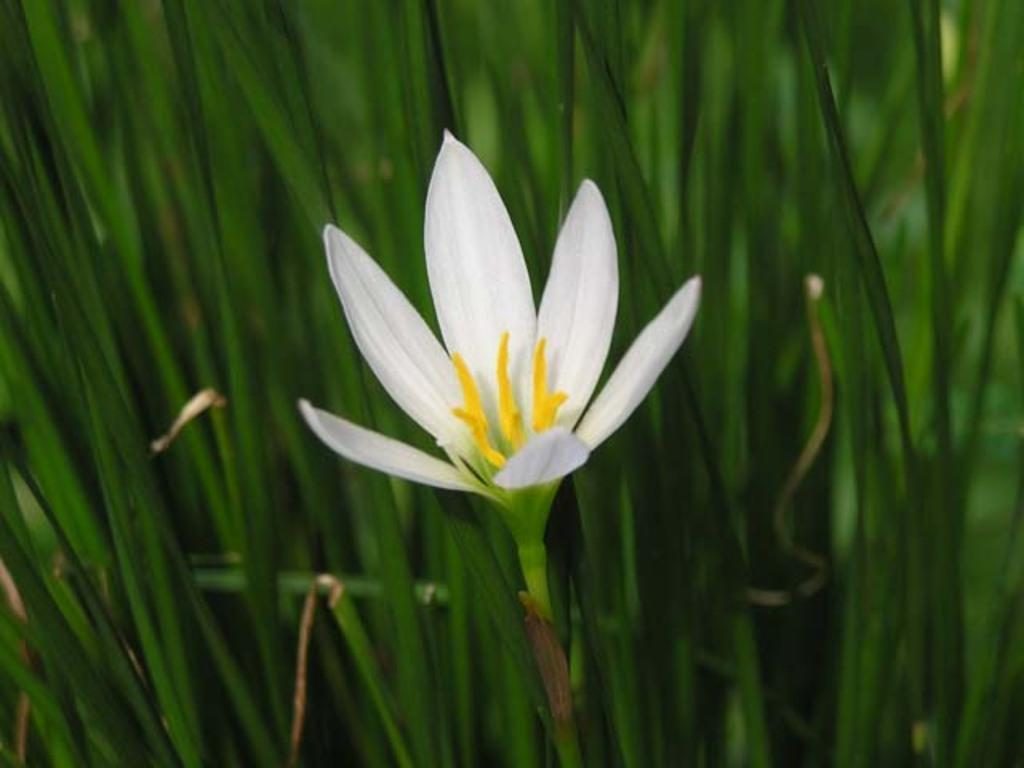What type of flower is in the image? There is a white color flower in the image. What else can be seen in the image besides the flower? There are leaves in the image. What are the petals like on the flower? Petals are visible on the flower. What is present on the flower that might be involved in pollination? Pollen grains are present on the flower. What type of poison is present on the flower in the image? There is no poison present on the flower in the image. 